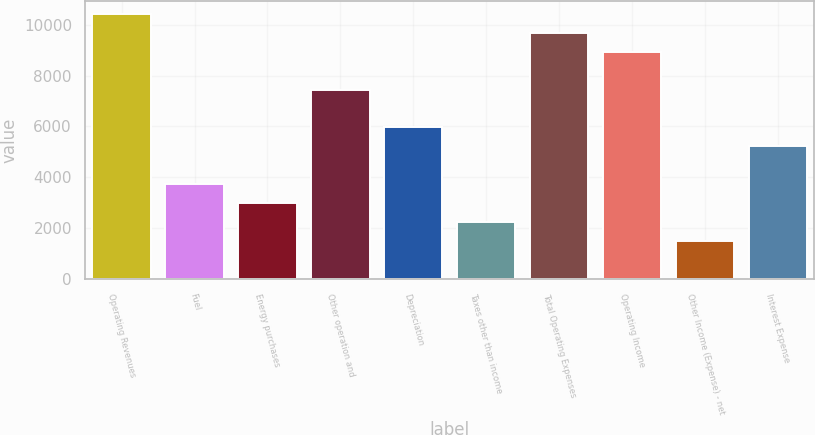<chart> <loc_0><loc_0><loc_500><loc_500><bar_chart><fcel>Operating Revenues<fcel>Fuel<fcel>Energy purchases<fcel>Other operation and<fcel>Depreciation<fcel>Taxes other than income<fcel>Total Operating Expenses<fcel>Operating Income<fcel>Other Income (Expense) - net<fcel>Interest Expense<nl><fcel>10425.2<fcel>3724.34<fcel>2979.8<fcel>7447.04<fcel>5957.96<fcel>2235.26<fcel>9680.66<fcel>8936.12<fcel>1490.72<fcel>5213.42<nl></chart> 